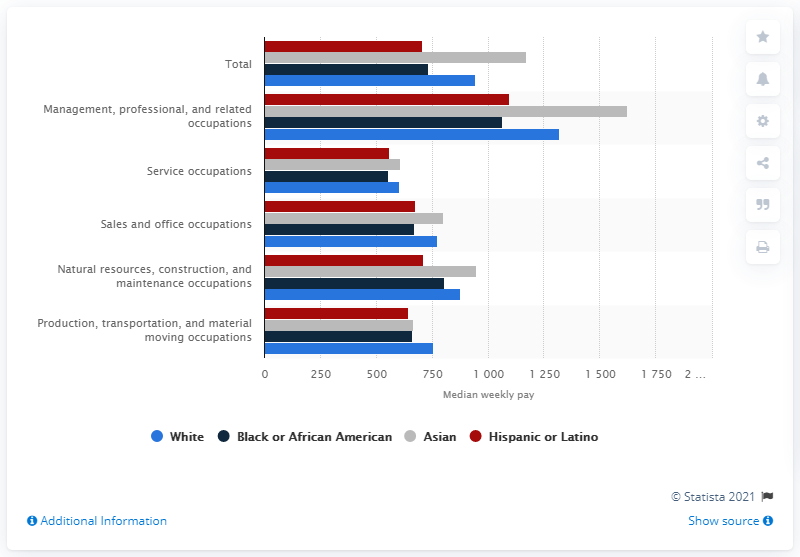Mention a couple of crucial points in this snapshot. In 2019, the median weekly earnings of Asian wage and salary workers employed in service occupations was $607. 